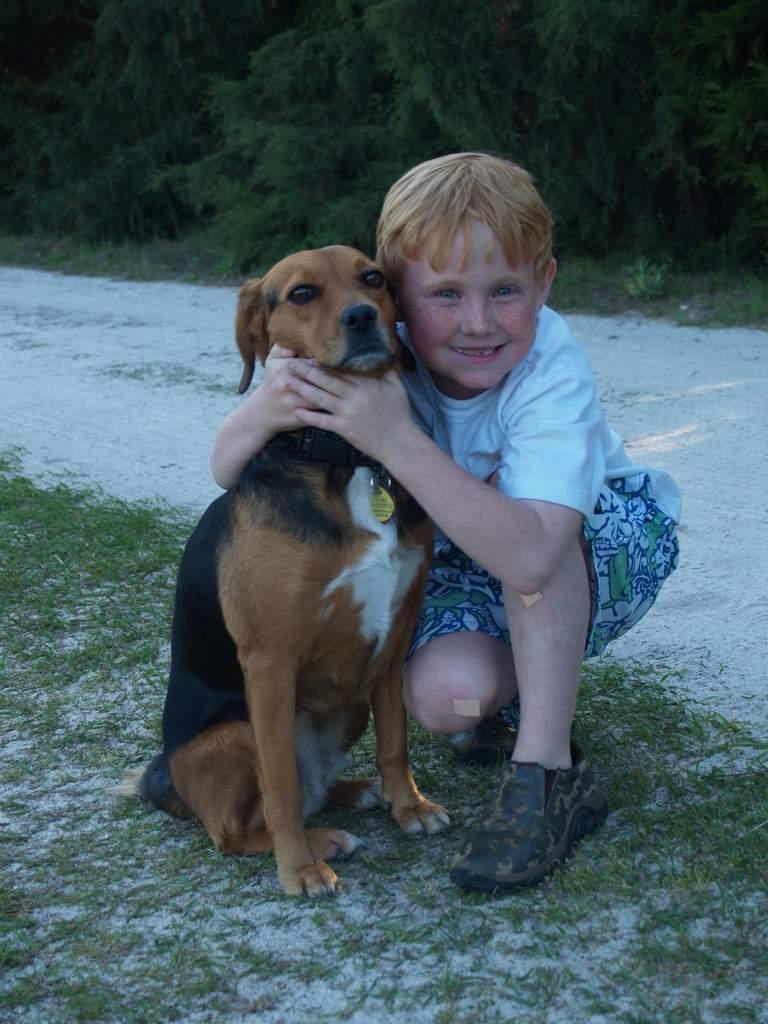Please provide a concise description of this image. In the center of the image we can see a boy and a dog. In the background there are trees. At the bottom there is grass. 